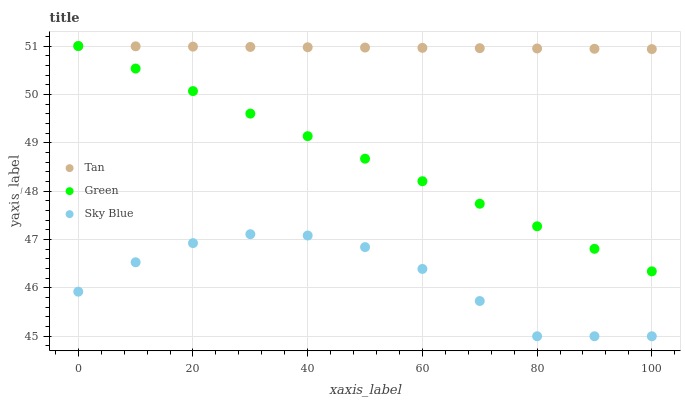Does Sky Blue have the minimum area under the curve?
Answer yes or no. Yes. Does Tan have the maximum area under the curve?
Answer yes or no. Yes. Does Green have the minimum area under the curve?
Answer yes or no. No. Does Green have the maximum area under the curve?
Answer yes or no. No. Is Green the smoothest?
Answer yes or no. Yes. Is Sky Blue the roughest?
Answer yes or no. Yes. Is Tan the smoothest?
Answer yes or no. No. Is Tan the roughest?
Answer yes or no. No. Does Sky Blue have the lowest value?
Answer yes or no. Yes. Does Green have the lowest value?
Answer yes or no. No. Does Green have the highest value?
Answer yes or no. Yes. Is Sky Blue less than Tan?
Answer yes or no. Yes. Is Tan greater than Sky Blue?
Answer yes or no. Yes. Does Tan intersect Green?
Answer yes or no. Yes. Is Tan less than Green?
Answer yes or no. No. Is Tan greater than Green?
Answer yes or no. No. Does Sky Blue intersect Tan?
Answer yes or no. No. 